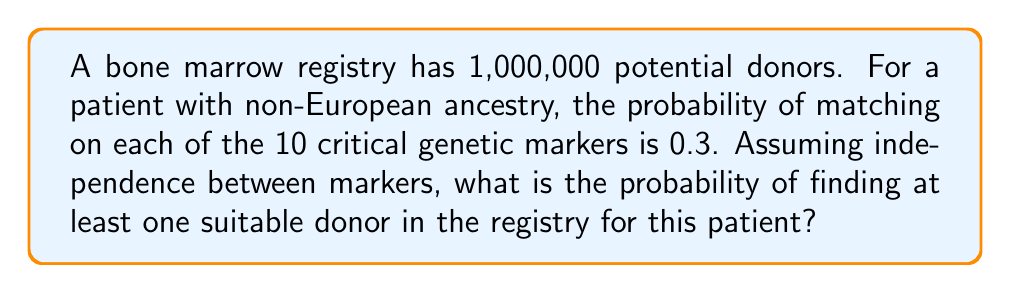Teach me how to tackle this problem. Let's approach this problem step-by-step:

1) First, we need to calculate the probability of a single donor being a match. For this, we need to match all 10 genetic markers.

   Probability of matching all 10 markers = $0.3^{10} = 5.9049 \times 10^{-6}$

2) Now, let's calculate the probability of a single donor not being a match:

   Probability of not matching = $1 - 5.9049 \times 10^{-6} = 0.9999940951$

3) For the patient to not find a match, all 1,000,000 donors must not be a match. We can calculate this as:

   Probability of no match in the registry = $(0.9999940951)^{1,000,000}$

4) Therefore, the probability of finding at least one match is the complement of this:

   Probability of at least one match = $1 - (0.9999940951)^{1,000,000}$

5) We can simplify this calculation using the approximation $1 - (1-x)^n \approx nx$ when $x$ is small and $n$ is large:

   $1 - (1 - 5.9049 \times 10^{-6})^{1,000,000} \approx 1,000,000 \times 5.9049 \times 10^{-6} = 0.59049$

6) To get a more precise answer, we can use a calculator:

   $1 - (0.9999940951)^{1,000,000} \approx 0.5724$

Thus, the probability of finding at least one suitable donor is approximately 0.5724 or 57.24%.
Answer: The probability of finding at least one suitable donor in the registry is approximately 0.5724 or 57.24%. 